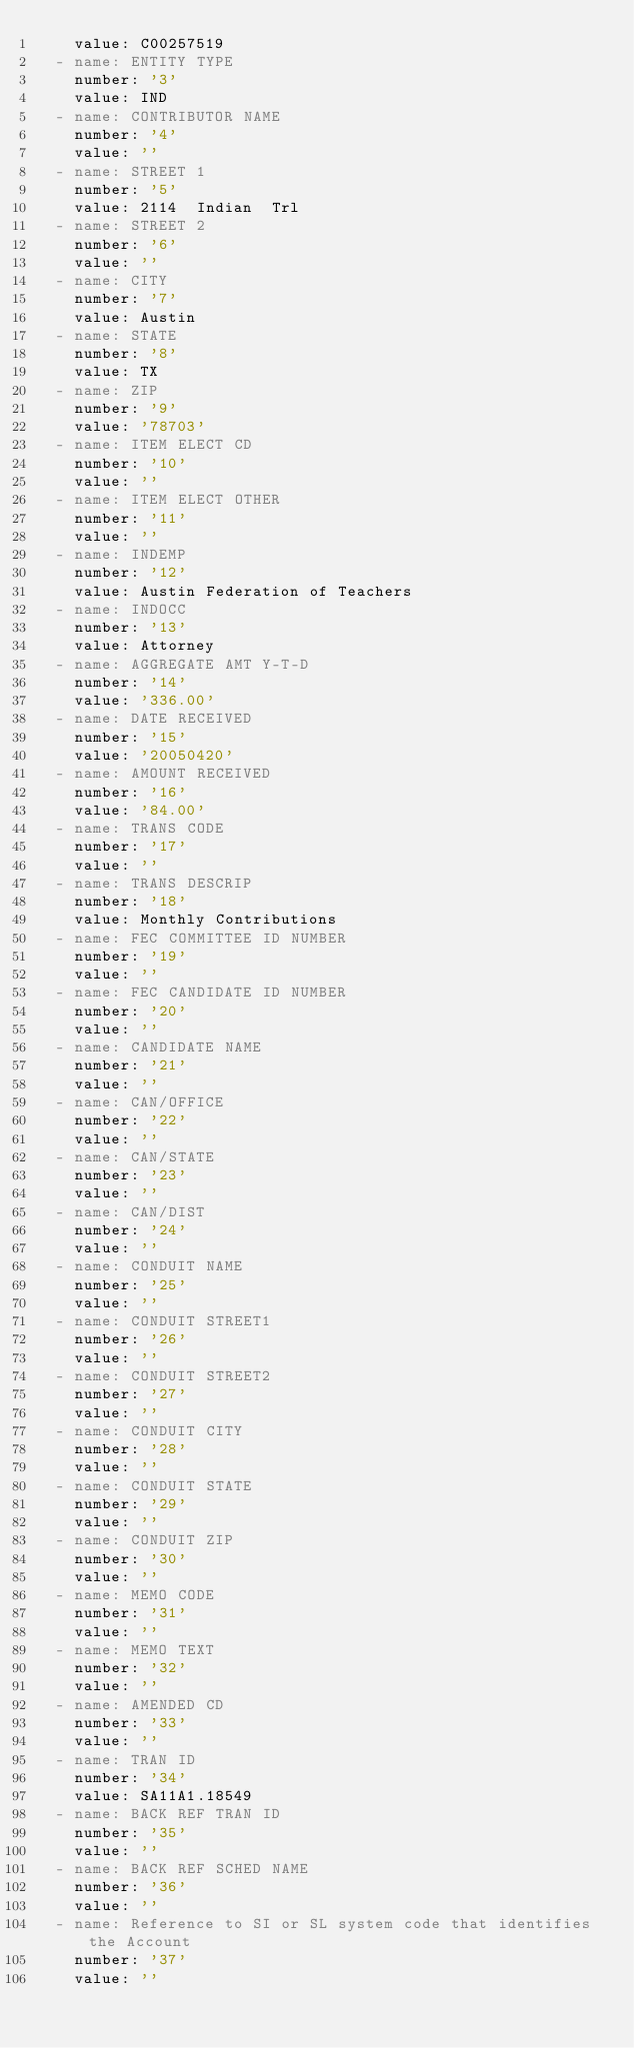Convert code to text. <code><loc_0><loc_0><loc_500><loc_500><_YAML_>    value: C00257519
  - name: ENTITY TYPE
    number: '3'
    value: IND
  - name: CONTRIBUTOR NAME
    number: '4'
    value: ''
  - name: STREET 1
    number: '5'
    value: 2114  Indian  Trl
  - name: STREET 2
    number: '6'
    value: ''
  - name: CITY
    number: '7'
    value: Austin
  - name: STATE
    number: '8'
    value: TX
  - name: ZIP
    number: '9'
    value: '78703'
  - name: ITEM ELECT CD
    number: '10'
    value: ''
  - name: ITEM ELECT OTHER
    number: '11'
    value: ''
  - name: INDEMP
    number: '12'
    value: Austin Federation of Teachers
  - name: INDOCC
    number: '13'
    value: Attorney
  - name: AGGREGATE AMT Y-T-D
    number: '14'
    value: '336.00'
  - name: DATE RECEIVED
    number: '15'
    value: '20050420'
  - name: AMOUNT RECEIVED
    number: '16'
    value: '84.00'
  - name: TRANS CODE
    number: '17'
    value: ''
  - name: TRANS DESCRIP
    number: '18'
    value: Monthly Contributions
  - name: FEC COMMITTEE ID NUMBER
    number: '19'
    value: ''
  - name: FEC CANDIDATE ID NUMBER
    number: '20'
    value: ''
  - name: CANDIDATE NAME
    number: '21'
    value: ''
  - name: CAN/OFFICE
    number: '22'
    value: ''
  - name: CAN/STATE
    number: '23'
    value: ''
  - name: CAN/DIST
    number: '24'
    value: ''
  - name: CONDUIT NAME
    number: '25'
    value: ''
  - name: CONDUIT STREET1
    number: '26'
    value: ''
  - name: CONDUIT STREET2
    number: '27'
    value: ''
  - name: CONDUIT CITY
    number: '28'
    value: ''
  - name: CONDUIT STATE
    number: '29'
    value: ''
  - name: CONDUIT ZIP
    number: '30'
    value: ''
  - name: MEMO CODE
    number: '31'
    value: ''
  - name: MEMO TEXT
    number: '32'
    value: ''
  - name: AMENDED CD
    number: '33'
    value: ''
  - name: TRAN ID
    number: '34'
    value: SA11A1.18549
  - name: BACK REF TRAN ID
    number: '35'
    value: ''
  - name: BACK REF SCHED NAME
    number: '36'
    value: ''
  - name: Reference to SI or SL system code that identifies the Account
    number: '37'
    value: ''</code> 